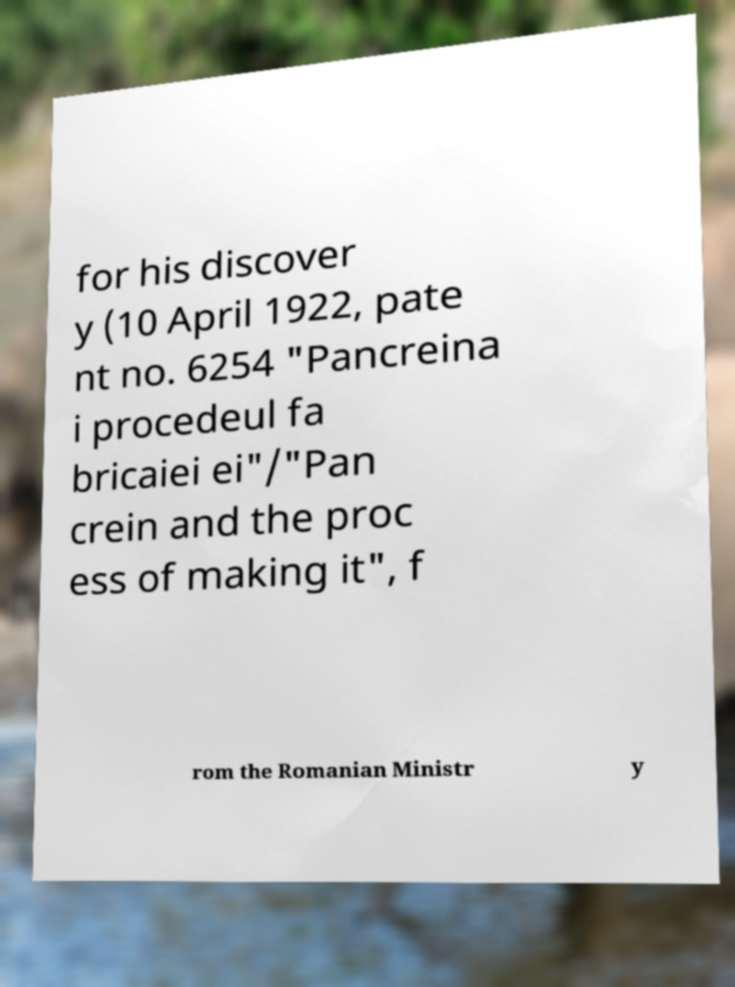Could you assist in decoding the text presented in this image and type it out clearly? for his discover y (10 April 1922, pate nt no. 6254 "Pancreina i procedeul fa bricaiei ei"/"Pan crein and the proc ess of making it", f rom the Romanian Ministr y 